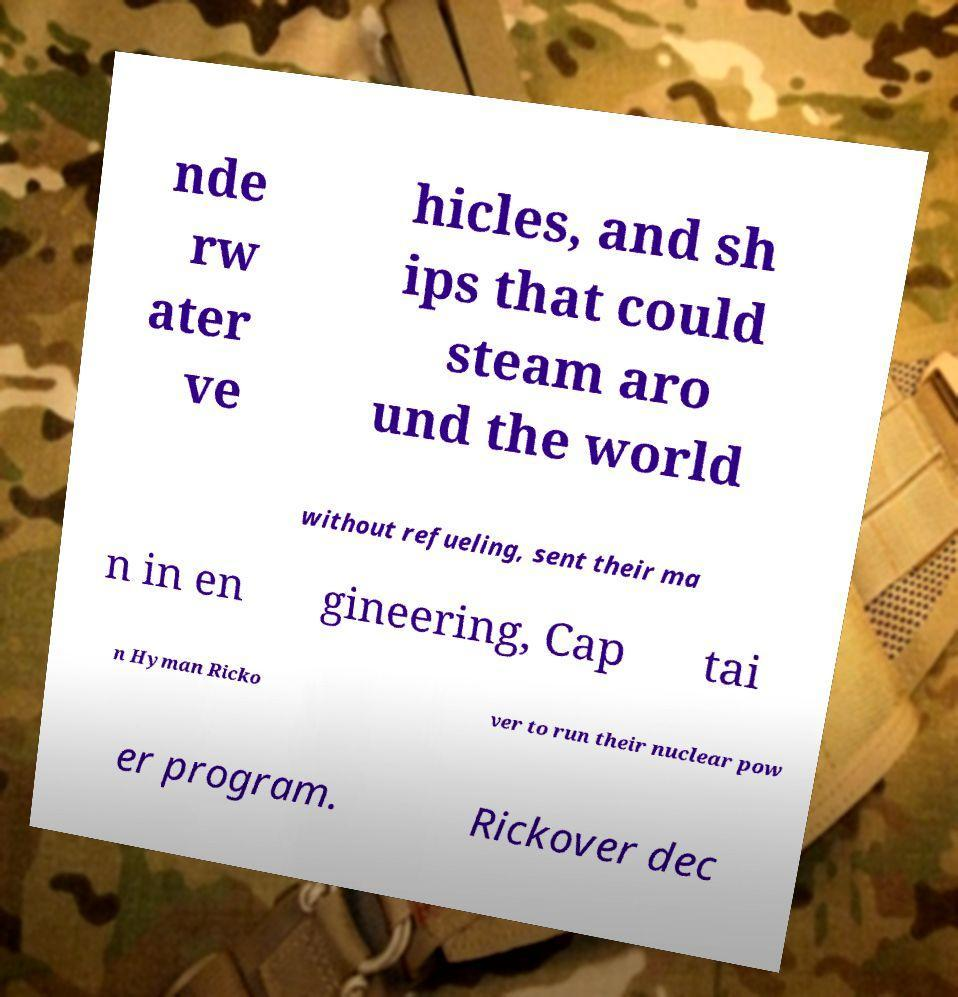Could you extract and type out the text from this image? nde rw ater ve hicles, and sh ips that could steam aro und the world without refueling, sent their ma n in en gineering, Cap tai n Hyman Ricko ver to run their nuclear pow er program. Rickover dec 